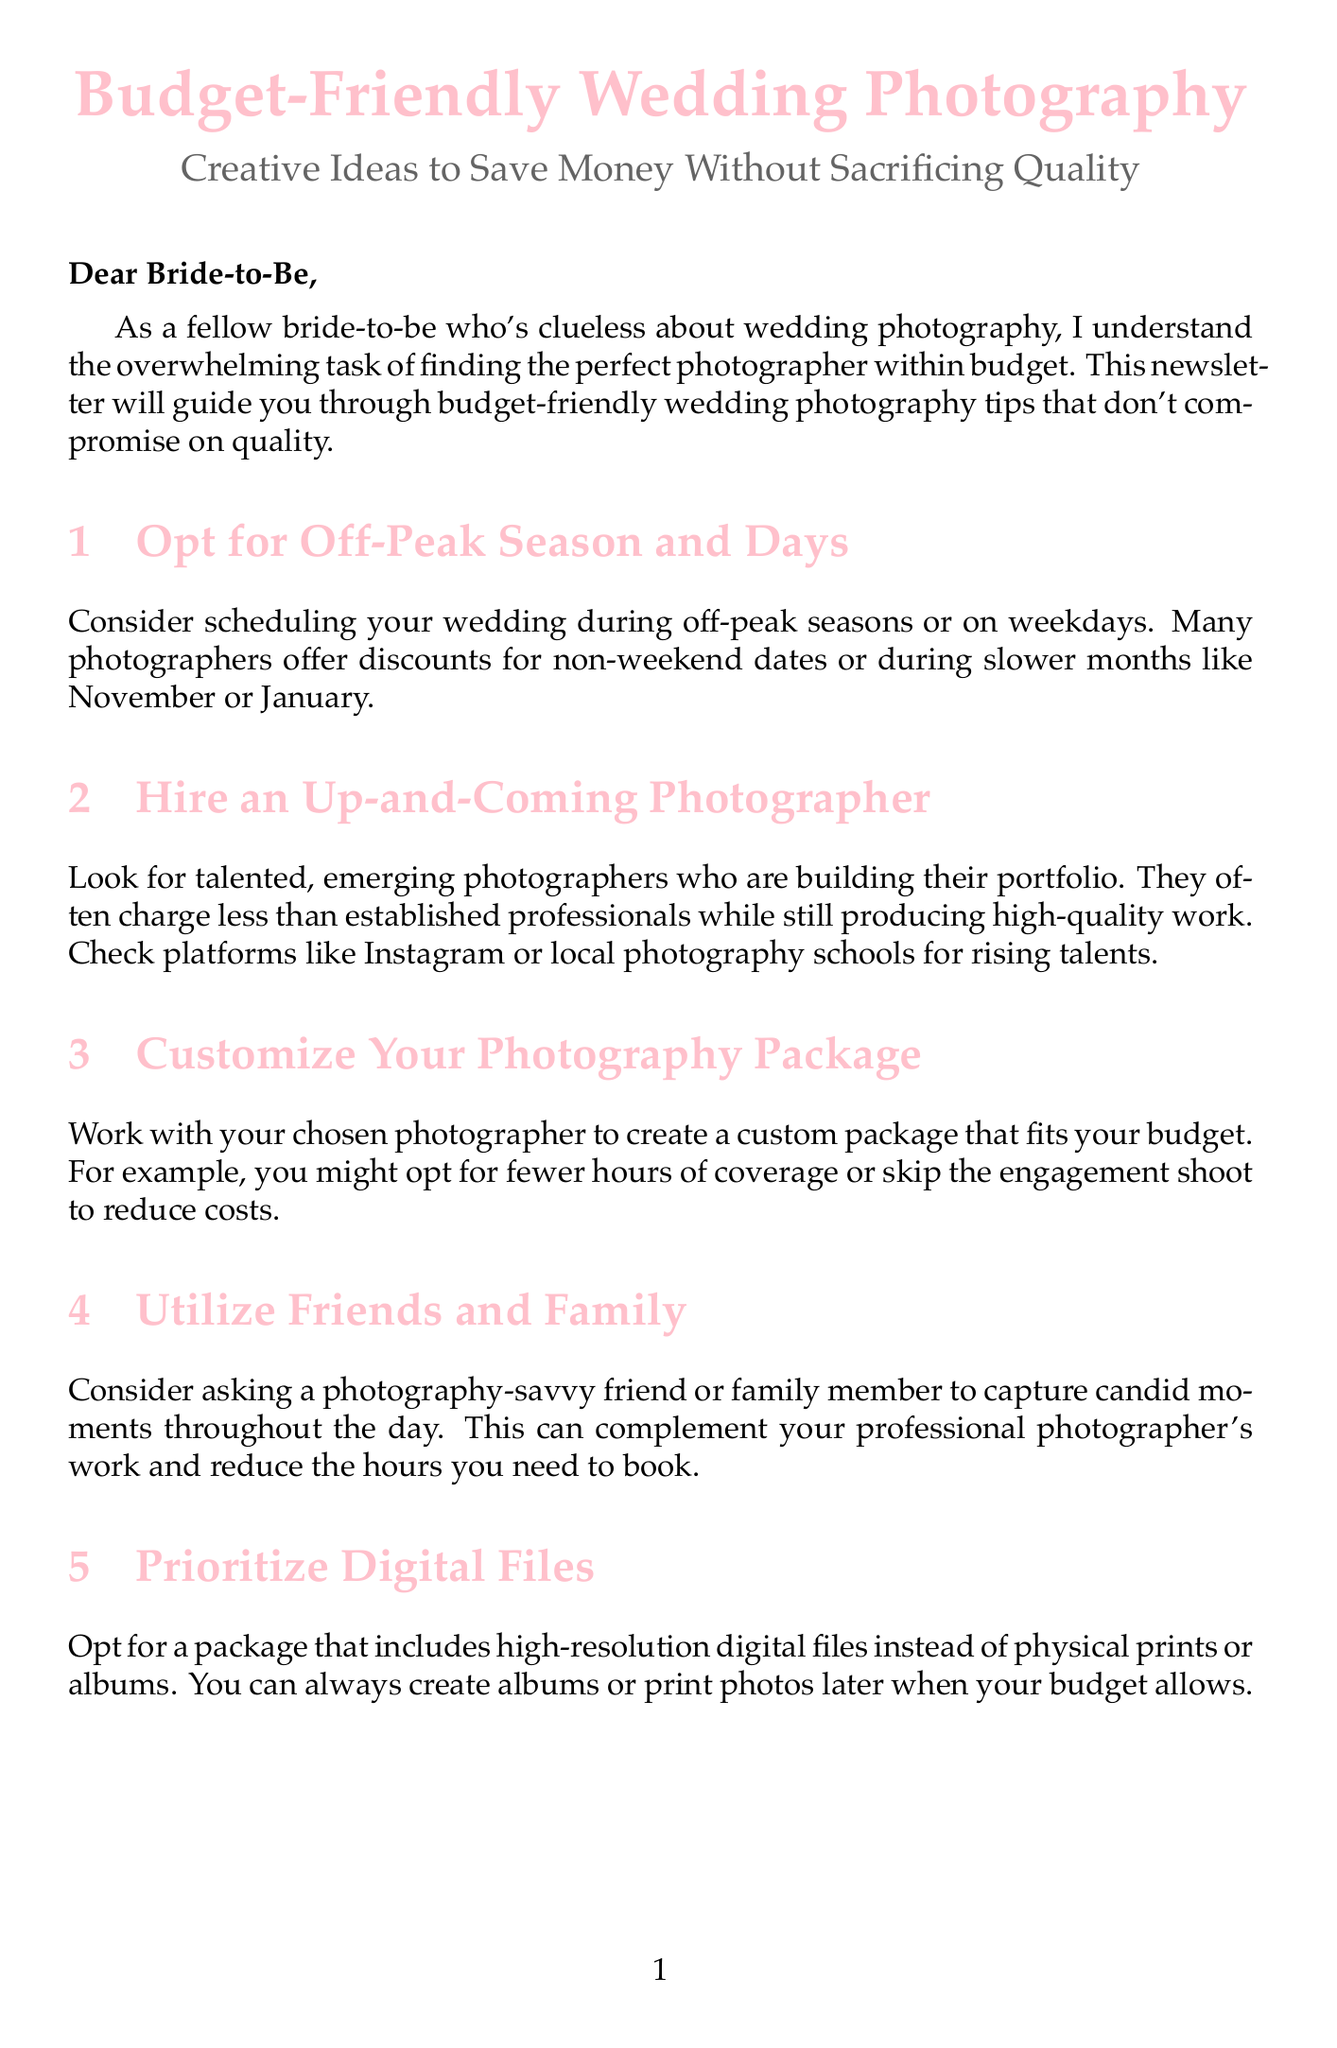What is the purpose of this newsletter? The purpose of the newsletter is to guide brides-to-be through budget-friendly wedding photography tips that don't compromise on quality.
Answer: Guide brides-to-be What month is mentioned as an off-peak season? November is listed as a slow month when photographers often offer discounts.
Answer: November Who is featured for natural light and candid moments? Emily Chen Photography is noted for specializing in natural light and candid moments.
Answer: Emily Chen Photography Which app is suggested for crowdsourcing guest photos? The document recommends using the app WedPics for collecting guest photos.
Answer: WedPics What type of photography package can be customized? The package that can be customized is the photography package that fits your budget.
Answer: Photography package How many featured photographers are mentioned in the newsletter? Three featured photographers are listed in the newsletter.
Answer: Three What is a suggested way to reduce photographer coverage? Utilizing a photography-savvy friend or family member is suggested to reduce the hours needed to book a professional photographer.
Answer: Utilizing friends and family What can you prioritize over physical prints or albums? The newsletter advises prioritizing digital files instead of physical prints or albums for budget reasons.
Answer: Digital files What is the suggested method to negotiate with photographers? Brides-to-be are encouraged to ask for discounts for paying in full upfront or to include additional services within their budget.
Answer: Negotiate discounts 